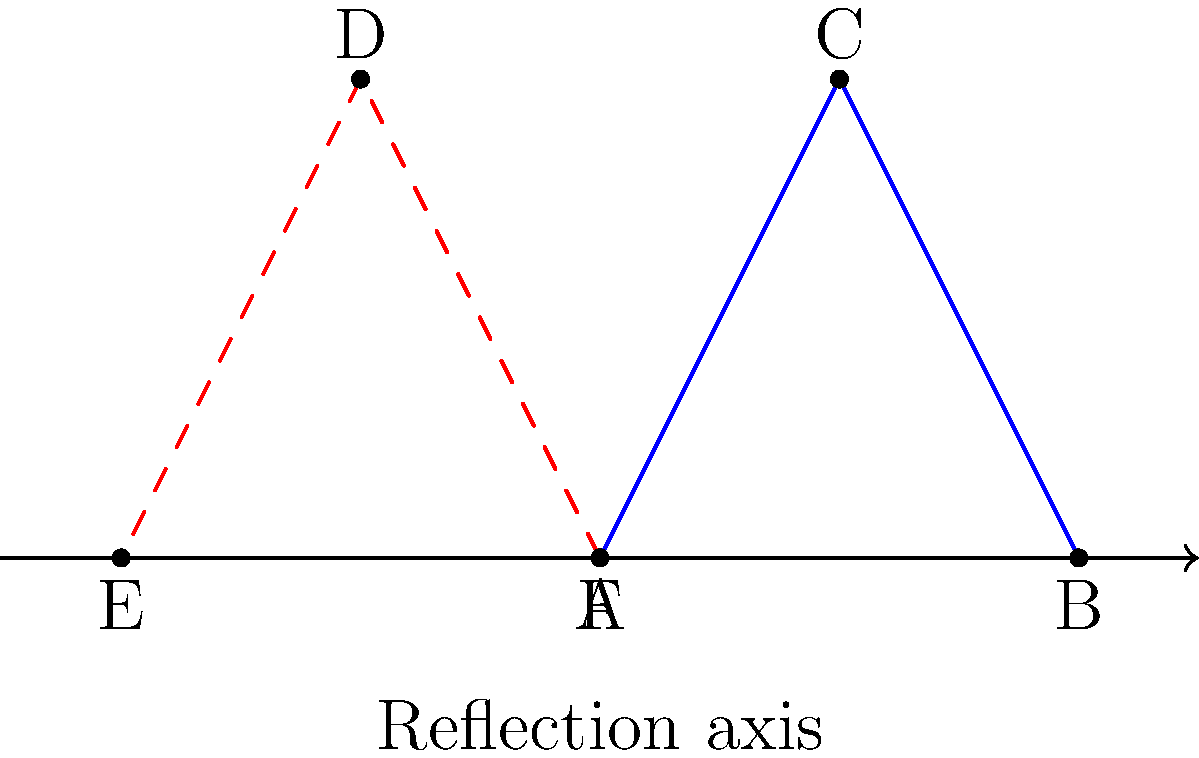As a collector of fine jewelry, you've acquired a unique symmetrical pendant (triangle ABC). To create a matching pair for your collection, you decide to reflect the pendant across a vertical axis. What are the coordinates of point D, which is the reflection of point C? To find the coordinates of point D, we need to reflect point C across the y-axis. Here's how we can do this step-by-step:

1. Identify the coordinates of point C: $C(1,2)$

2. The reflection across the y-axis will:
   - Change the sign of the x-coordinate
   - Keep the y-coordinate the same

3. Applying the reflection:
   - New x-coordinate: $-1$ (the opposite of 1)
   - New y-coordinate: $2$ (remains the same)

4. Therefore, the coordinates of point D are $(-1,2)$

This reflection creates a mirror image of the original pendant, forming a perfect matching pair for your collection.
Answer: $D(-1,2)$ 